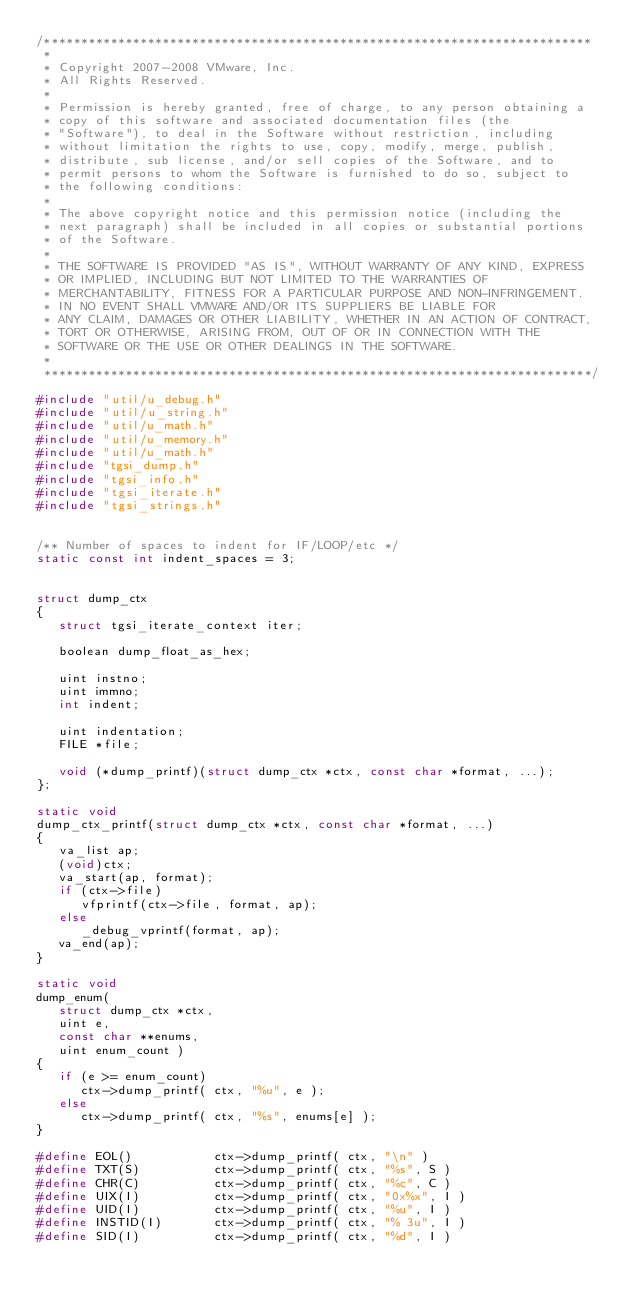Convert code to text. <code><loc_0><loc_0><loc_500><loc_500><_C_>/**************************************************************************
 * 
 * Copyright 2007-2008 VMware, Inc.
 * All Rights Reserved.
 * 
 * Permission is hereby granted, free of charge, to any person obtaining a
 * copy of this software and associated documentation files (the
 * "Software"), to deal in the Software without restriction, including
 * without limitation the rights to use, copy, modify, merge, publish,
 * distribute, sub license, and/or sell copies of the Software, and to
 * permit persons to whom the Software is furnished to do so, subject to
 * the following conditions:
 * 
 * The above copyright notice and this permission notice (including the
 * next paragraph) shall be included in all copies or substantial portions
 * of the Software.
 * 
 * THE SOFTWARE IS PROVIDED "AS IS", WITHOUT WARRANTY OF ANY KIND, EXPRESS
 * OR IMPLIED, INCLUDING BUT NOT LIMITED TO THE WARRANTIES OF
 * MERCHANTABILITY, FITNESS FOR A PARTICULAR PURPOSE AND NON-INFRINGEMENT.
 * IN NO EVENT SHALL VMWARE AND/OR ITS SUPPLIERS BE LIABLE FOR
 * ANY CLAIM, DAMAGES OR OTHER LIABILITY, WHETHER IN AN ACTION OF CONTRACT,
 * TORT OR OTHERWISE, ARISING FROM, OUT OF OR IN CONNECTION WITH THE
 * SOFTWARE OR THE USE OR OTHER DEALINGS IN THE SOFTWARE.
 * 
 **************************************************************************/

#include "util/u_debug.h"
#include "util/u_string.h"
#include "util/u_math.h"
#include "util/u_memory.h"
#include "util/u_math.h"
#include "tgsi_dump.h"
#include "tgsi_info.h"
#include "tgsi_iterate.h"
#include "tgsi_strings.h"


/** Number of spaces to indent for IF/LOOP/etc */
static const int indent_spaces = 3;


struct dump_ctx
{
   struct tgsi_iterate_context iter;

   boolean dump_float_as_hex;

   uint instno;
   uint immno;
   int indent;
   
   uint indentation;
   FILE *file;

   void (*dump_printf)(struct dump_ctx *ctx, const char *format, ...);
};

static void 
dump_ctx_printf(struct dump_ctx *ctx, const char *format, ...)
{
   va_list ap;
   (void)ctx;
   va_start(ap, format);
   if (ctx->file)
      vfprintf(ctx->file, format, ap);
   else
      _debug_vprintf(format, ap);
   va_end(ap);
}

static void
dump_enum(
   struct dump_ctx *ctx,
   uint e,
   const char **enums,
   uint enum_count )
{
   if (e >= enum_count)
      ctx->dump_printf( ctx, "%u", e );
   else
      ctx->dump_printf( ctx, "%s", enums[e] );
}

#define EOL()           ctx->dump_printf( ctx, "\n" )
#define TXT(S)          ctx->dump_printf( ctx, "%s", S )
#define CHR(C)          ctx->dump_printf( ctx, "%c", C )
#define UIX(I)          ctx->dump_printf( ctx, "0x%x", I )
#define UID(I)          ctx->dump_printf( ctx, "%u", I )
#define INSTID(I)       ctx->dump_printf( ctx, "% 3u", I )
#define SID(I)          ctx->dump_printf( ctx, "%d", I )</code> 